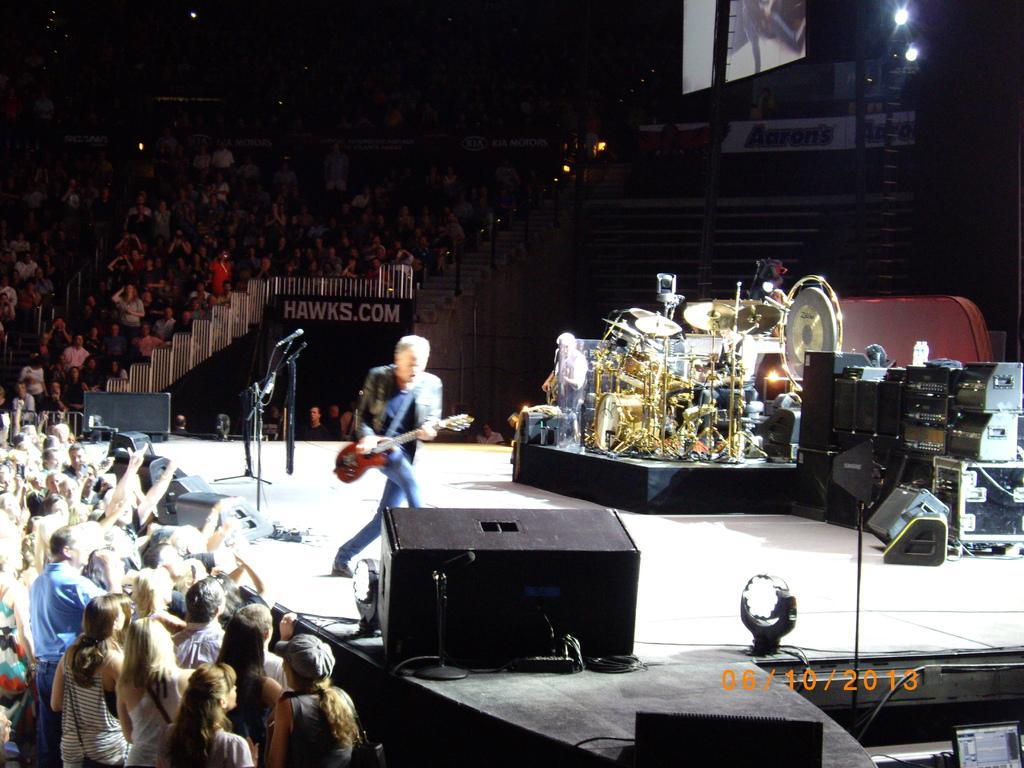How would you summarize this image in a sentence or two? Here I can see a person is playing the guitar by standing on the stage. On the right side there are many musical instruments placed on the stage. On the left side I can see a crowd of people facing towards the stage. In the background I can see a screen, few lights and some other objects in the dark. This is looking like an inside view of an auditorium. 